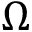<formula> <loc_0><loc_0><loc_500><loc_500>\Omega</formula> 